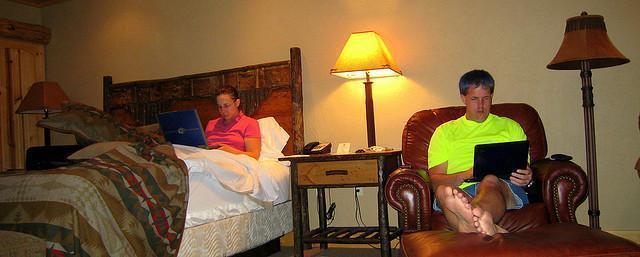Why are they so far apart?
From the following set of four choices, select the accurate answer to respond to the question.
Options: Too crowded, quiet time, afraid, strangers. Quiet time. 